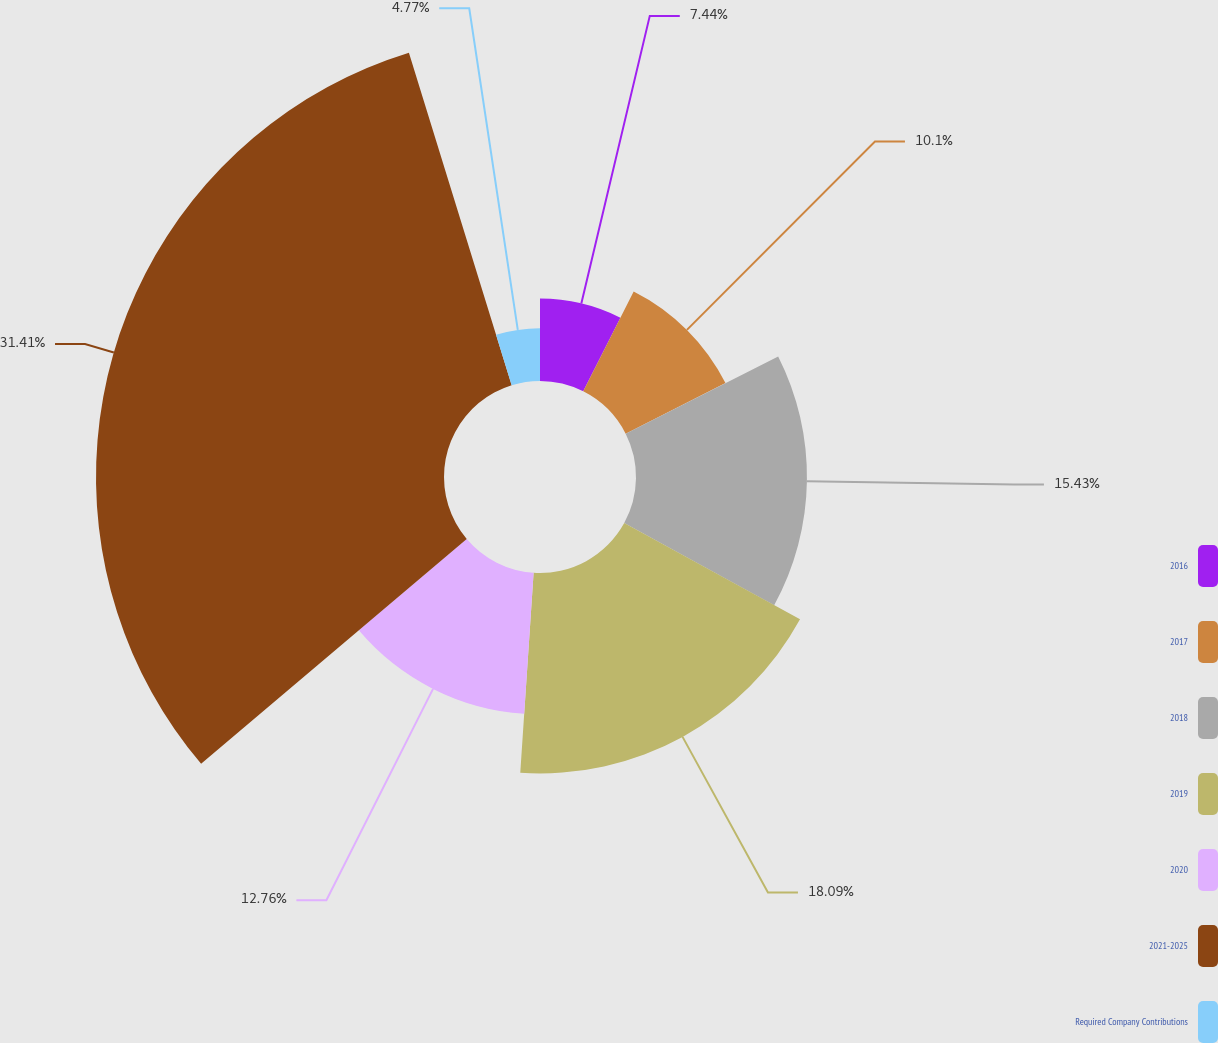Convert chart to OTSL. <chart><loc_0><loc_0><loc_500><loc_500><pie_chart><fcel>2016<fcel>2017<fcel>2018<fcel>2019<fcel>2020<fcel>2021-2025<fcel>Required Company Contributions<nl><fcel>7.44%<fcel>10.1%<fcel>15.43%<fcel>18.09%<fcel>12.76%<fcel>31.41%<fcel>4.77%<nl></chart> 